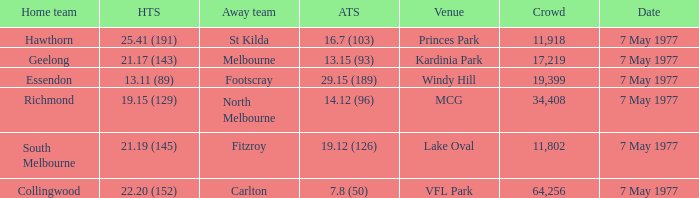Name the home team score for larger crowd than 11,918 for windy hill venue 13.11 (89). 